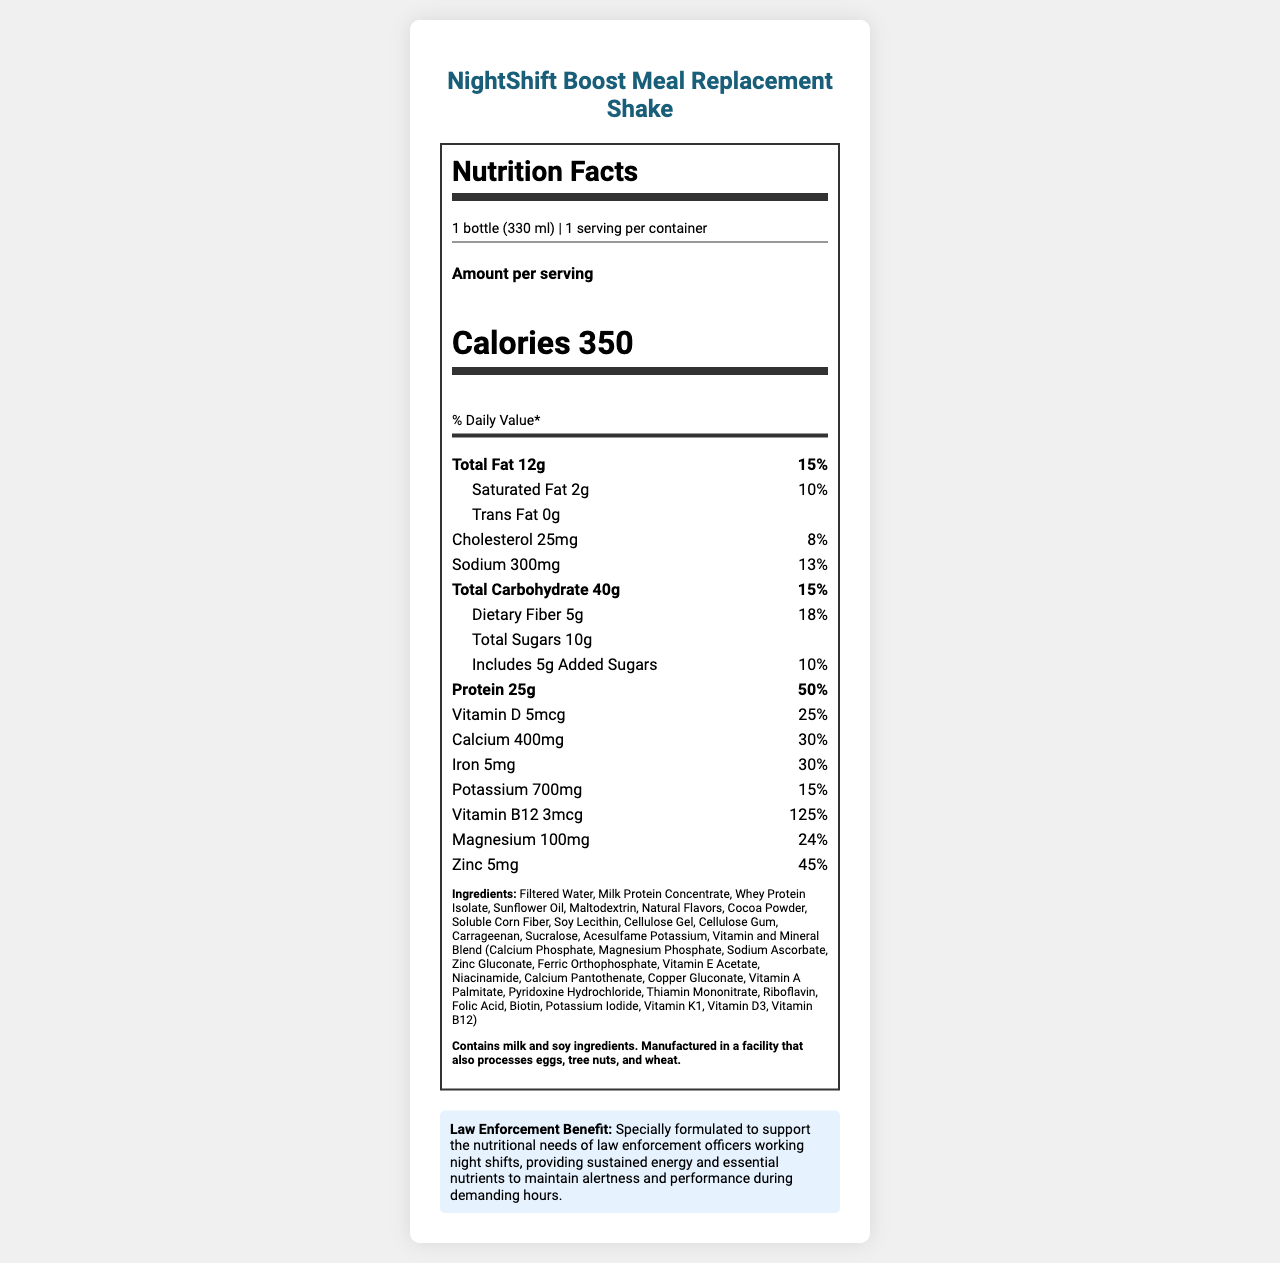what is the serving size of the NightShift Boost Meal Replacement Shake? The serving size is explicitly mentioned in the document as "1 bottle (330 ml)".
Answer: 1 bottle (330 ml) how many grams of protein are in one serving of the shake? The document lists the amount of protein per serving as 25g.
Answer: 25g what is the percentage daily value of calcium in the shake? The document states that the percentage daily value for calcium is 30%.
Answer: 30% does the shake contain any trans fat? The document specifies that the trans fat content is 0g, indicating no trans fat is present.
Answer: No what vitamins and minerals are included in the vitamin and mineral blend? The document lists all the vitamins and minerals in the blend. They are contained within the ingredients list, under "Vitamin and Mineral Blend".
Answer: Calcium Phosphate, Magnesium Phosphate, Sodium Ascorbate, Zinc Gluconate, Ferric Orthophosphate, Vitamin E Acetate, Niacinamide, Calcium Pantothenate, Copper Gluconate, Vitamin A Palmitate, Pyridoxine Hydrochloride, Thiamin Mononitrate, Riboflavin, Folic Acid, Biotin, Potassium Iodide, Vitamin K1, Vitamin D3, Vitamin B12 does the product contain any allergens? The document contains an allergen warning stating that the product contains milk and soy ingredients.
Answer: Yes what is the total calorie content per serving? The total calorie content per serving is stated as 350 calories.
Answer: 350 calories what is the law enforcement benefit of the shake? The document provides this specific information as a "Law Enforcement Benefit" section at the end.
Answer: Specially formulated to support the nutritional needs of law enforcement officers working night shifts, providing sustained energy and essential nutrients to maintain alertness and performance during demanding hours. which of the following ingredients does the shake contain? A. High Fructose Corn Syrup B. Maltodextrin C. Artificial Flavors D. Palm Oil The document lists Maltodextrin as an ingredient, while the others are not included.
Answer: B. Maltodextrin what percentage of the daily value for protein is provided by the shake? A. 25% B. 50% C. 75% D. 100% The document states the daily value for protein as 50%.
Answer: B. 50% does the product contain added sugars? True or False The document shows that the shake contains 5g of added sugars.
Answer: True summarize the main features of the NightShift Boost Meal Replacement Shake. This summary describes the major features and benefits as provided in the document, encapsulating the nutritional content and specific use case for night shift law enforcement officers.
Answer: The NightShift Boost Meal Replacement Shake is a specially formulated product designed for night shift workers, particularly law enforcement officers, providing essential nutrients and sustained energy. Each 330 ml bottle contains 350 calories, 25g of protein, and significant amounts of vitamins and minerals, such as calcium, iron, and vitamin B12. It contains fats, carbohydrates, and dietary fiber, with no trans fat and low added sugars. It also lists several allergens and includes a blend of various vitamins and minerals. what is the total manufacturing cost of the NightShift Boost Meal Replacement Shake? The document does not provide any information regarding the manufacturing cost of the product.
Answer: Cannot be determined 